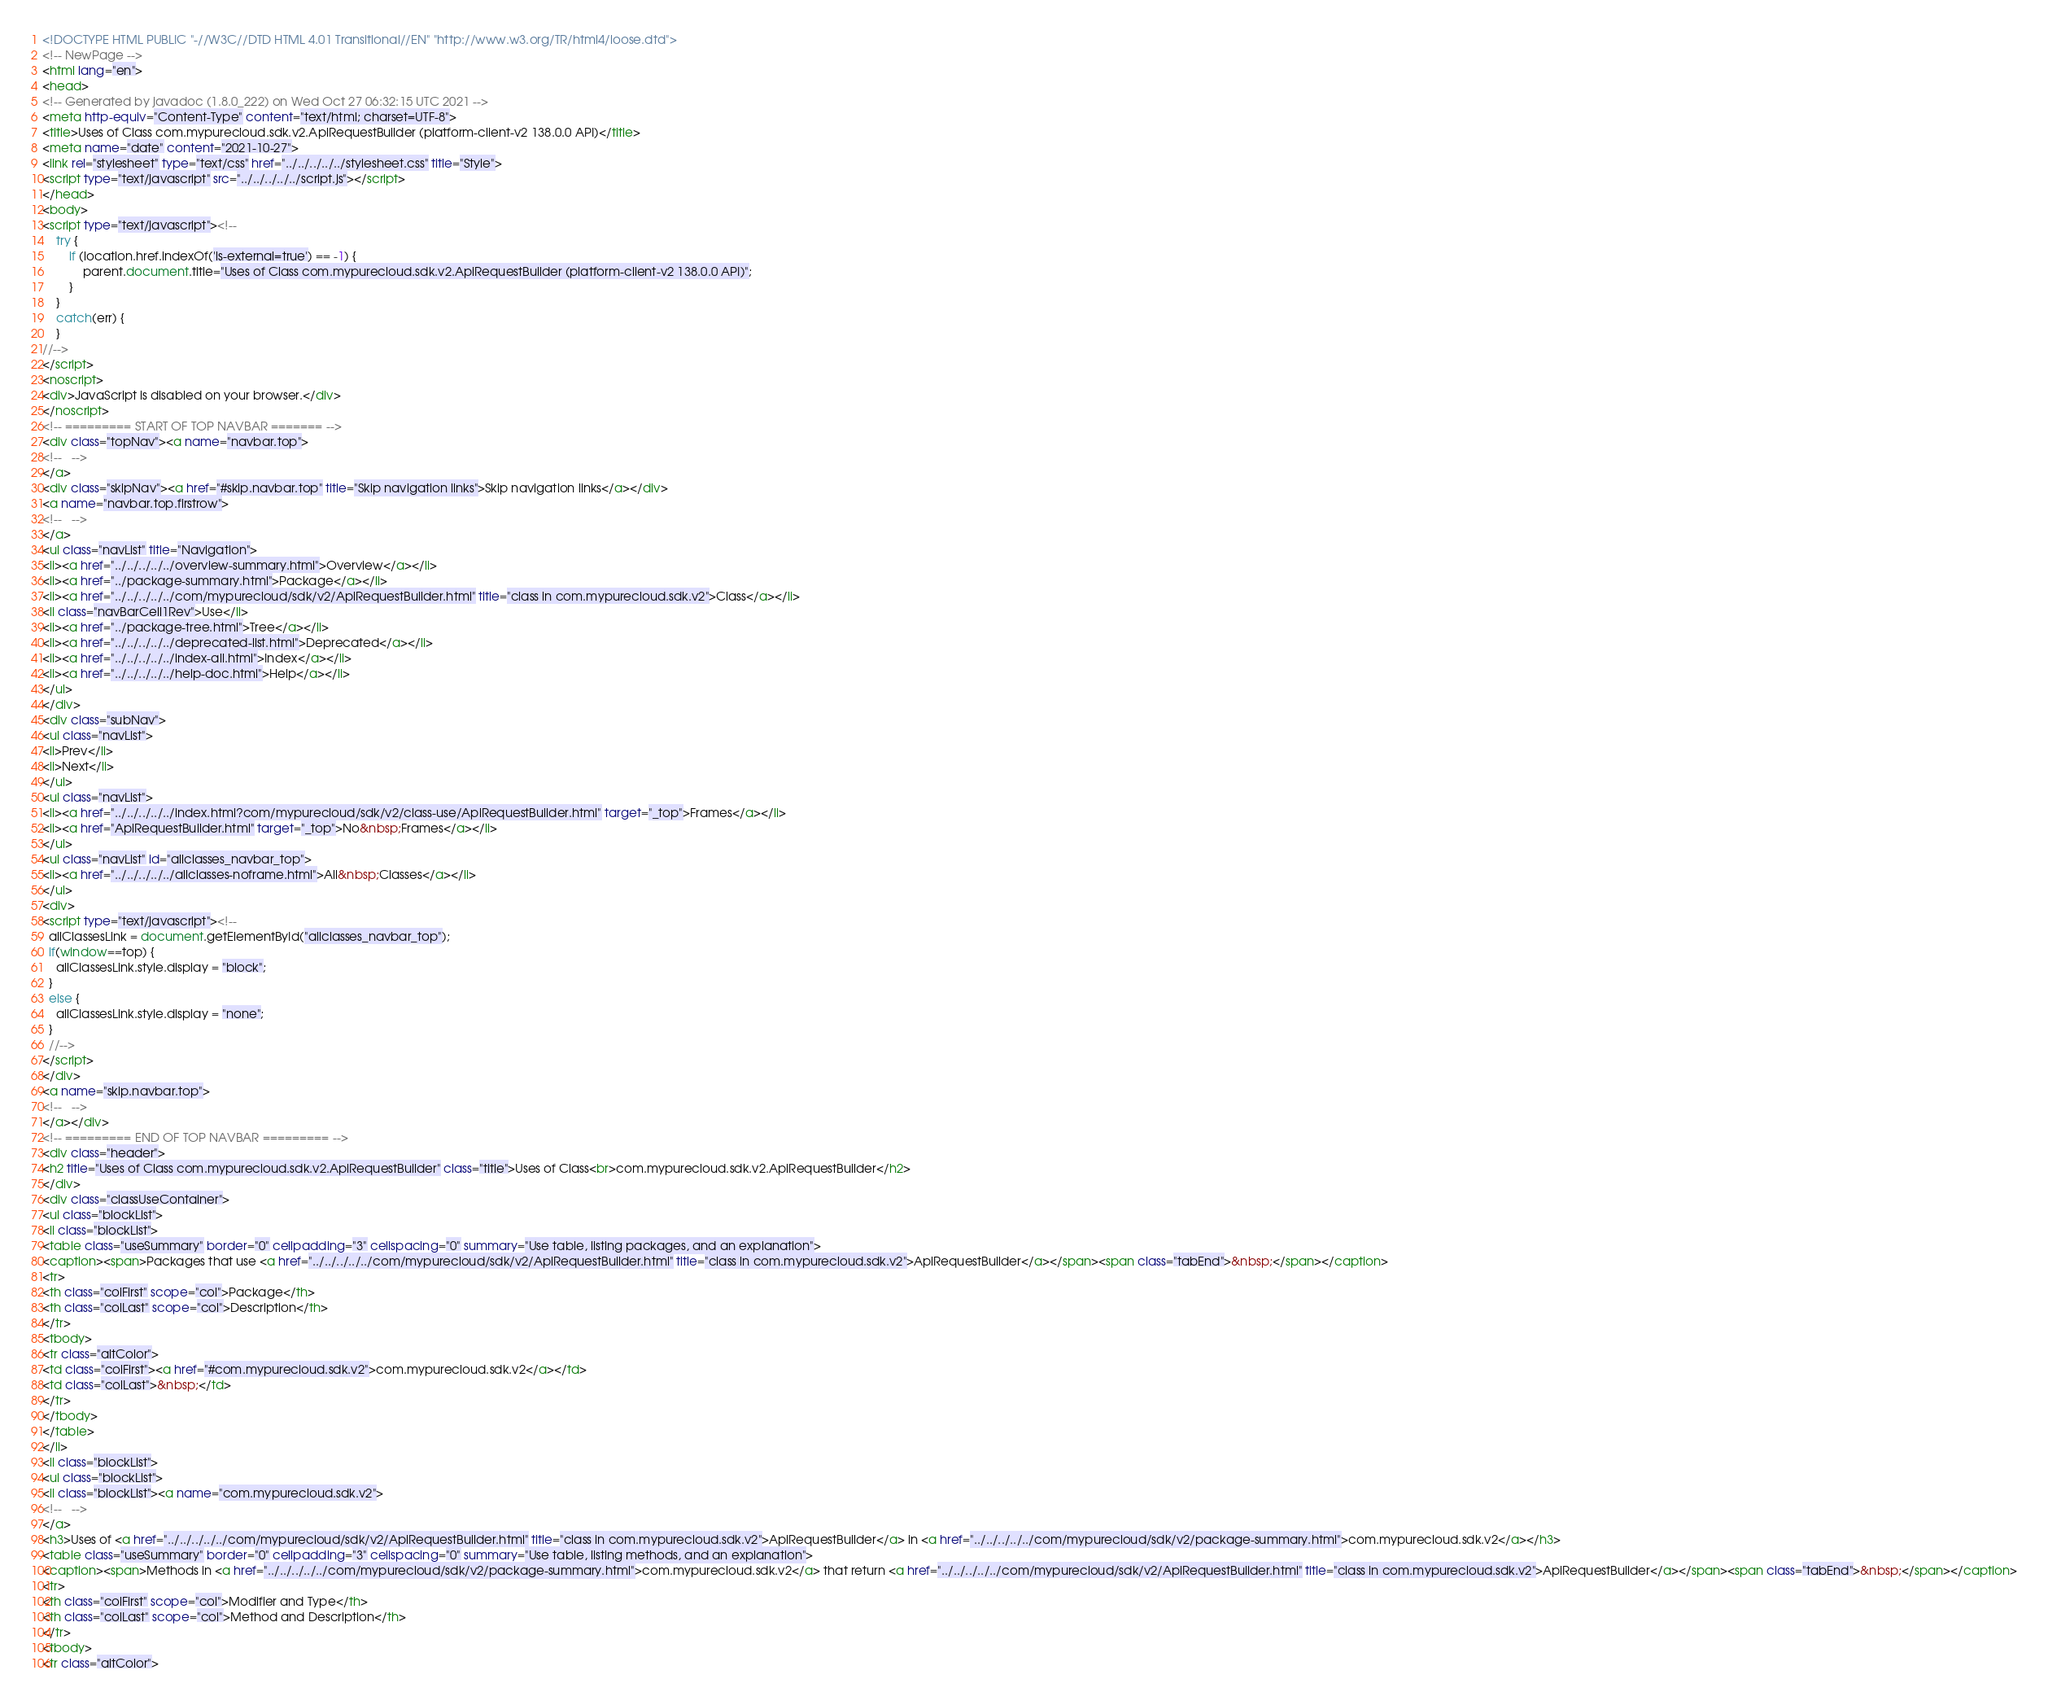Convert code to text. <code><loc_0><loc_0><loc_500><loc_500><_HTML_><!DOCTYPE HTML PUBLIC "-//W3C//DTD HTML 4.01 Transitional//EN" "http://www.w3.org/TR/html4/loose.dtd">
<!-- NewPage -->
<html lang="en">
<head>
<!-- Generated by javadoc (1.8.0_222) on Wed Oct 27 06:32:15 UTC 2021 -->
<meta http-equiv="Content-Type" content="text/html; charset=UTF-8">
<title>Uses of Class com.mypurecloud.sdk.v2.ApiRequestBuilder (platform-client-v2 138.0.0 API)</title>
<meta name="date" content="2021-10-27">
<link rel="stylesheet" type="text/css" href="../../../../../stylesheet.css" title="Style">
<script type="text/javascript" src="../../../../../script.js"></script>
</head>
<body>
<script type="text/javascript"><!--
    try {
        if (location.href.indexOf('is-external=true') == -1) {
            parent.document.title="Uses of Class com.mypurecloud.sdk.v2.ApiRequestBuilder (platform-client-v2 138.0.0 API)";
        }
    }
    catch(err) {
    }
//-->
</script>
<noscript>
<div>JavaScript is disabled on your browser.</div>
</noscript>
<!-- ========= START OF TOP NAVBAR ======= -->
<div class="topNav"><a name="navbar.top">
<!--   -->
</a>
<div class="skipNav"><a href="#skip.navbar.top" title="Skip navigation links">Skip navigation links</a></div>
<a name="navbar.top.firstrow">
<!--   -->
</a>
<ul class="navList" title="Navigation">
<li><a href="../../../../../overview-summary.html">Overview</a></li>
<li><a href="../package-summary.html">Package</a></li>
<li><a href="../../../../../com/mypurecloud/sdk/v2/ApiRequestBuilder.html" title="class in com.mypurecloud.sdk.v2">Class</a></li>
<li class="navBarCell1Rev">Use</li>
<li><a href="../package-tree.html">Tree</a></li>
<li><a href="../../../../../deprecated-list.html">Deprecated</a></li>
<li><a href="../../../../../index-all.html">Index</a></li>
<li><a href="../../../../../help-doc.html">Help</a></li>
</ul>
</div>
<div class="subNav">
<ul class="navList">
<li>Prev</li>
<li>Next</li>
</ul>
<ul class="navList">
<li><a href="../../../../../index.html?com/mypurecloud/sdk/v2/class-use/ApiRequestBuilder.html" target="_top">Frames</a></li>
<li><a href="ApiRequestBuilder.html" target="_top">No&nbsp;Frames</a></li>
</ul>
<ul class="navList" id="allclasses_navbar_top">
<li><a href="../../../../../allclasses-noframe.html">All&nbsp;Classes</a></li>
</ul>
<div>
<script type="text/javascript"><!--
  allClassesLink = document.getElementById("allclasses_navbar_top");
  if(window==top) {
    allClassesLink.style.display = "block";
  }
  else {
    allClassesLink.style.display = "none";
  }
  //-->
</script>
</div>
<a name="skip.navbar.top">
<!--   -->
</a></div>
<!-- ========= END OF TOP NAVBAR ========= -->
<div class="header">
<h2 title="Uses of Class com.mypurecloud.sdk.v2.ApiRequestBuilder" class="title">Uses of Class<br>com.mypurecloud.sdk.v2.ApiRequestBuilder</h2>
</div>
<div class="classUseContainer">
<ul class="blockList">
<li class="blockList">
<table class="useSummary" border="0" cellpadding="3" cellspacing="0" summary="Use table, listing packages, and an explanation">
<caption><span>Packages that use <a href="../../../../../com/mypurecloud/sdk/v2/ApiRequestBuilder.html" title="class in com.mypurecloud.sdk.v2">ApiRequestBuilder</a></span><span class="tabEnd">&nbsp;</span></caption>
<tr>
<th class="colFirst" scope="col">Package</th>
<th class="colLast" scope="col">Description</th>
</tr>
<tbody>
<tr class="altColor">
<td class="colFirst"><a href="#com.mypurecloud.sdk.v2">com.mypurecloud.sdk.v2</a></td>
<td class="colLast">&nbsp;</td>
</tr>
</tbody>
</table>
</li>
<li class="blockList">
<ul class="blockList">
<li class="blockList"><a name="com.mypurecloud.sdk.v2">
<!--   -->
</a>
<h3>Uses of <a href="../../../../../com/mypurecloud/sdk/v2/ApiRequestBuilder.html" title="class in com.mypurecloud.sdk.v2">ApiRequestBuilder</a> in <a href="../../../../../com/mypurecloud/sdk/v2/package-summary.html">com.mypurecloud.sdk.v2</a></h3>
<table class="useSummary" border="0" cellpadding="3" cellspacing="0" summary="Use table, listing methods, and an explanation">
<caption><span>Methods in <a href="../../../../../com/mypurecloud/sdk/v2/package-summary.html">com.mypurecloud.sdk.v2</a> that return <a href="../../../../../com/mypurecloud/sdk/v2/ApiRequestBuilder.html" title="class in com.mypurecloud.sdk.v2">ApiRequestBuilder</a></span><span class="tabEnd">&nbsp;</span></caption>
<tr>
<th class="colFirst" scope="col">Modifier and Type</th>
<th class="colLast" scope="col">Method and Description</th>
</tr>
<tbody>
<tr class="altColor"></code> 